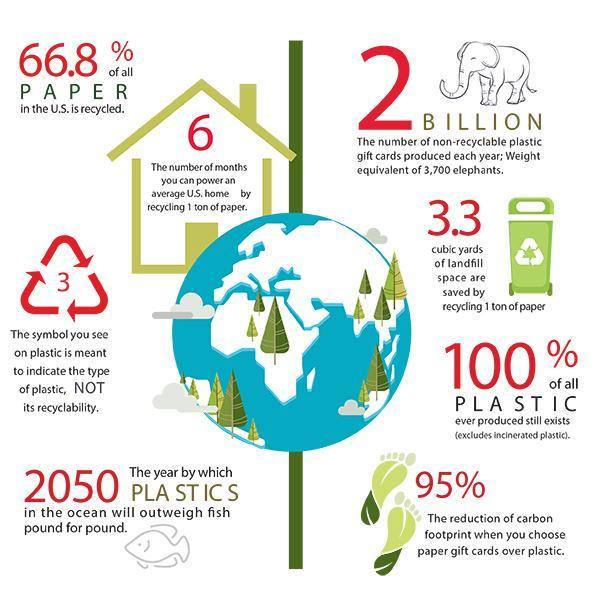What is the number of non-recyclable plastic gift cards produced each year in the U.S.?
Answer the question with a short phrase. 2 BILLION What percentage of all paper in the U.S. is not recycled? 33.2% 